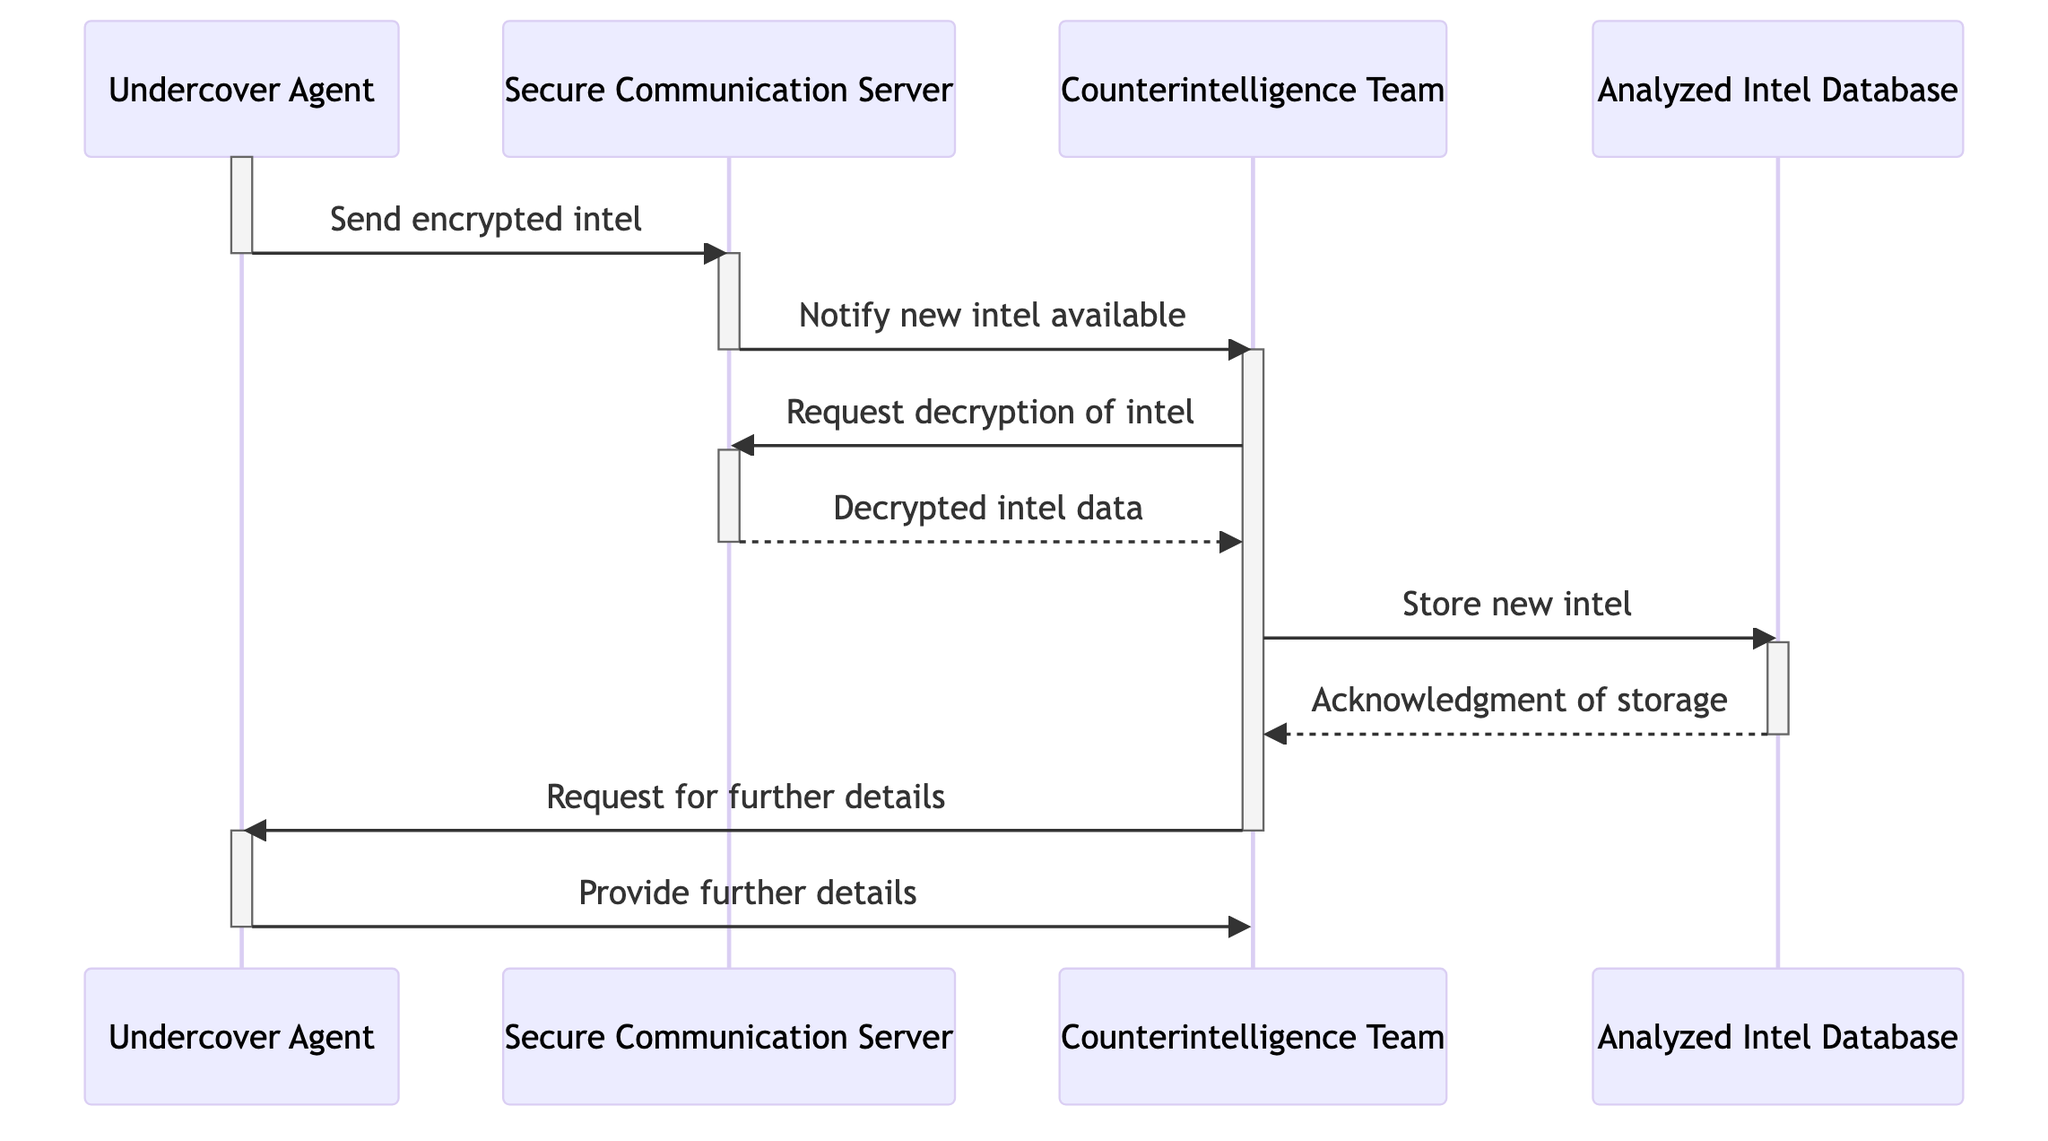What are the entities involved in the communication flow? The diagram includes four entities: Counterintelligence Team, Undercover Agent, Secure Communication Server, and Analyzed Intel Database.
Answer: Counterintelligence Team, Undercover Agent, Secure Communication Server, Analyzed Intel Database How many asynchronous messages are sent in total? The diagram shows three asynchronous messages: 1) Send encrypted intel, 2) Notify new intel available, and 3) Request for further details.
Answer: Three What message does the Secure Communication Server send to the Counterintelligence Team? The Secure Communication Server sends the message "Notify new intel available" to the Counterintelligence Team.
Answer: Notify new intel available How many replies are made in the sequence? There are two replies in the sequence: 1) Decrypted intel data and 2) Acknowledgment of storage.
Answer: Two What type of message does the Undercover Agent send first? The first message sent by the Undercover Agent is an asynchronous message: "Send encrypted intel."
Answer: Send encrypted intel How does the Counterintelligence Team acknowledge the storage of new intel? The Counterintelligence Team receives an acknowledgment of storage from the Analyzed Intel Database in response to their request to store new intel.
Answer: Acknowledgment of storage What action does the Counterintelligence Team take after receiving decrypted intel data? After receiving decrypted intel data, the Counterintelligence Team stores the new intel in the Analyzed Intel Database.
Answer: Store new intel What is the relationship between the Undercover Agent and the Secure Communication Server? The Undercover Agent sends encrypted intel to the Secure Communication Server, indicating a direct communication relationship focusing on intel transmission.
Answer: Sends encrypted intel What occurs after the Secure Communication Server notifies the Counterintelligence Team? The Counterintelligence Team responds to the notification by requesting the decryption of the intel from the Secure Communication Server.
Answer: Request decryption of intel 